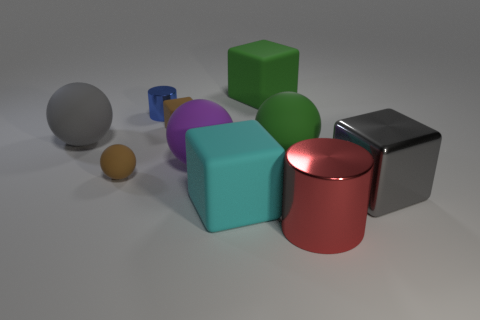Subtract all yellow blocks. Subtract all gray cylinders. How many blocks are left? 4 Subtract all spheres. How many objects are left? 6 Add 8 gray rubber spheres. How many gray rubber spheres are left? 9 Add 3 cyan metal blocks. How many cyan metal blocks exist? 3 Subtract 0 yellow balls. How many objects are left? 10 Subtract all big green rubber balls. Subtract all small rubber balls. How many objects are left? 8 